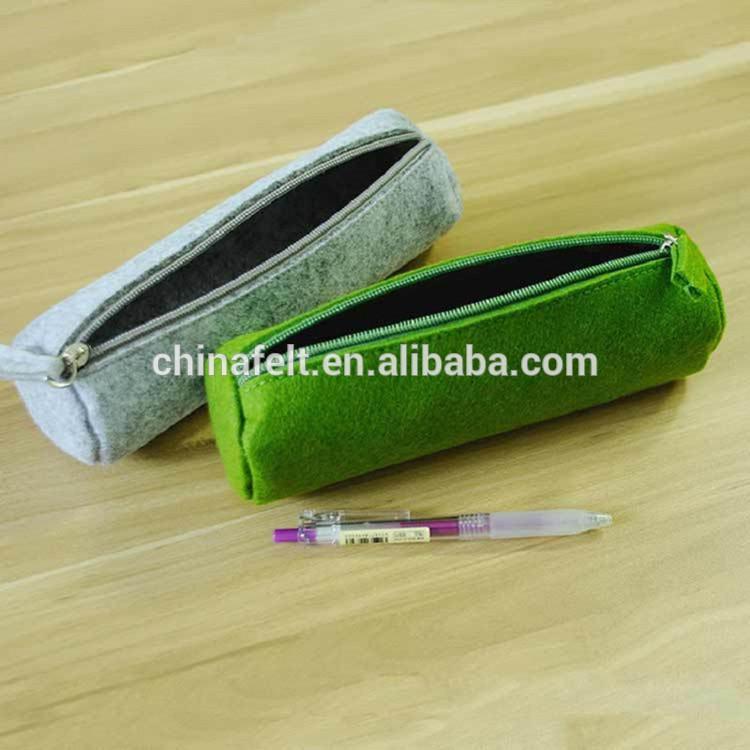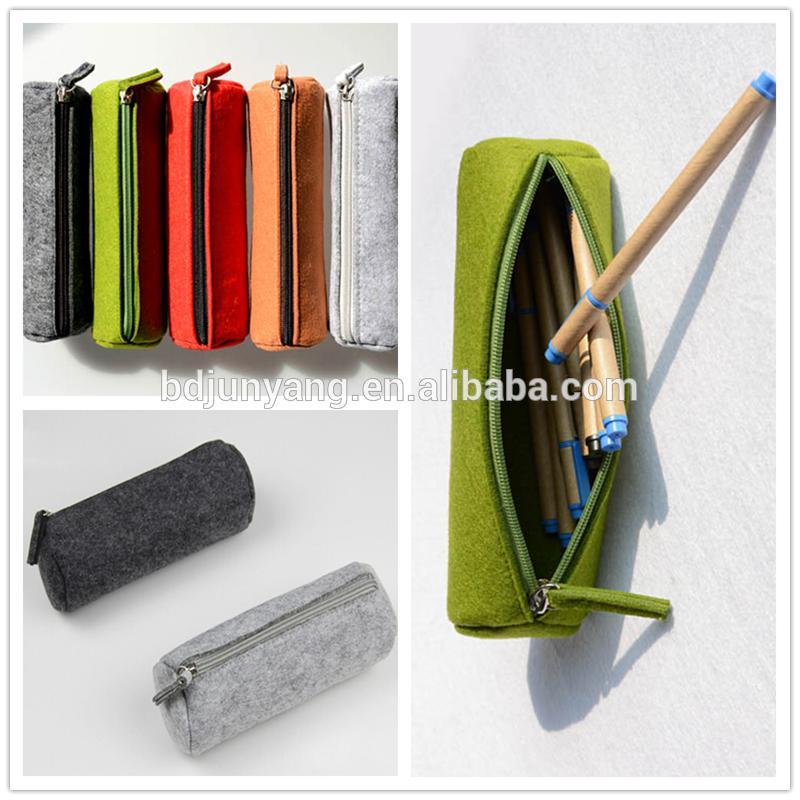The first image is the image on the left, the second image is the image on the right. Assess this claim about the two images: "There are five or more felt pencil cases.". Correct or not? Answer yes or no. Yes. The first image is the image on the left, the second image is the image on the right. Assess this claim about the two images: "The left image contains a gray tube-shaped zipper case to the left of a green one, and the right image includes gray, green and orange closed tube-shaped cases.". Correct or not? Answer yes or no. Yes. 